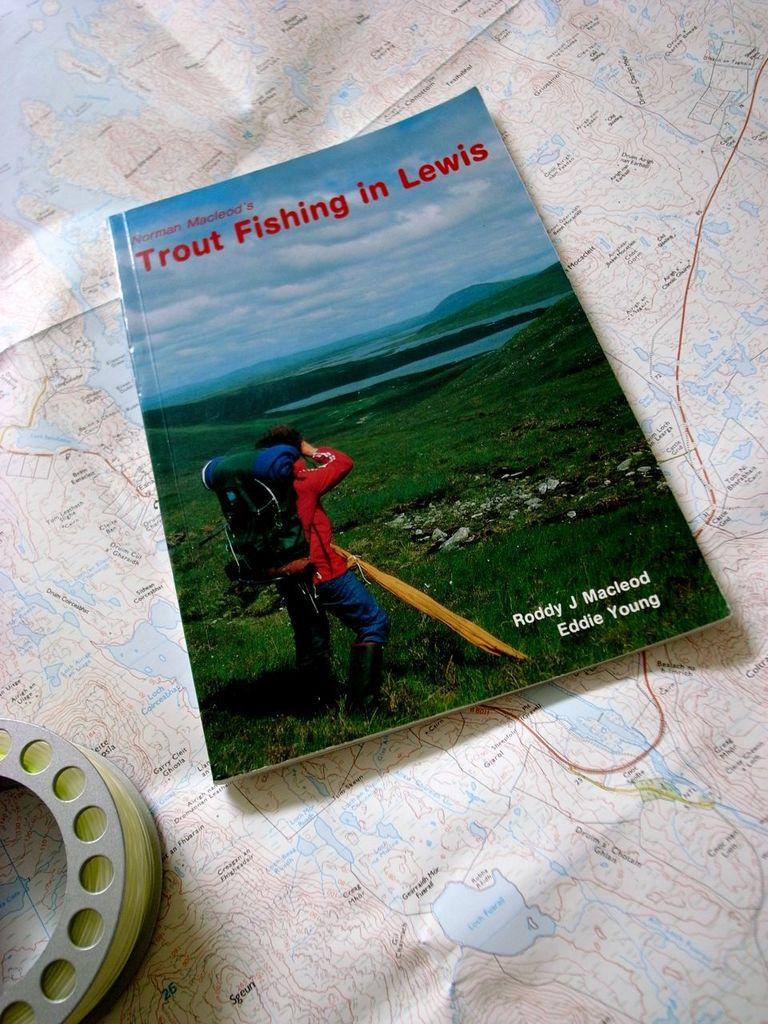What kind of fishing is this book about?
Make the answer very short. Trout. What is eddie's last name?
Keep it short and to the point. Young. 